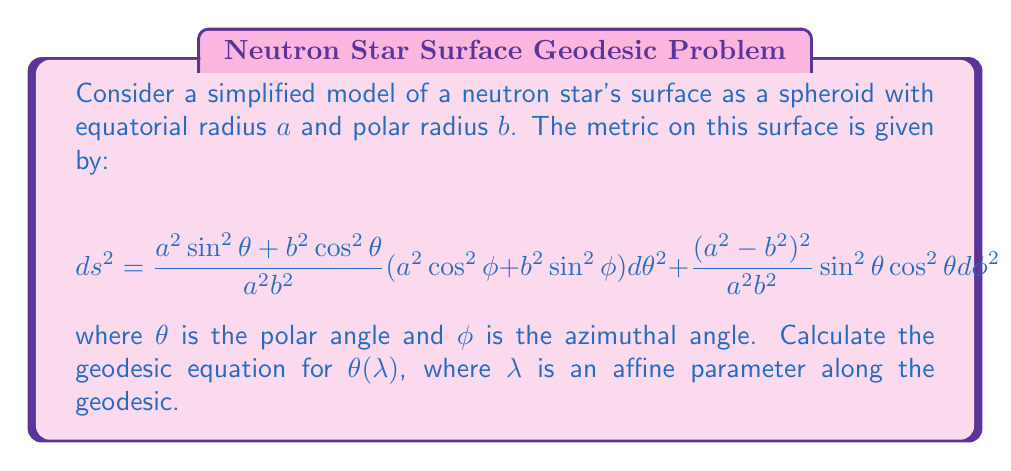Help me with this question. To find the geodesic equation for $\theta(\lambda)$, we'll use the Euler-Lagrange equation:

$$\frac{d}{d\lambda}\left(\frac{\partial L}{\partial \dot{\theta}}\right) - \frac{\partial L}{\partial \theta} = 0$$

where $L = \frac{1}{2}g_{\mu\nu}\frac{dx^\mu}{d\lambda}\frac{dx^\nu}{d\lambda}$ is the Lagrangian.

Step 1: Write out the Lagrangian
$$L = \frac{1}{2}\left[\frac{a^2\sin^2\theta + b^2\cos^2\theta}{a^2b^2}(a^2\cos^2\phi + b^2\sin^2\phi)\dot{\theta}^2 + \frac{(a^2-b^2)^2}{a^2b^2}\sin^2\theta\cos^2\theta \dot{\phi}^2\right]$$

Step 2: Calculate $\frac{\partial L}{\partial \dot{\theta}}$
$$\frac{\partial L}{\partial \dot{\theta}} = \frac{a^2\sin^2\theta + b^2\cos^2\theta}{a^2b^2}(a^2\cos^2\phi + b^2\sin^2\phi)\dot{\theta}$$

Step 3: Calculate $\frac{d}{d\lambda}\left(\frac{\partial L}{\partial \dot{\theta}}\right)$
$$\frac{d}{d\lambda}\left(\frac{\partial L}{\partial \dot{\theta}}\right) = \frac{d}{d\lambda}\left[\frac{a^2\sin^2\theta + b^2\cos^2\theta}{a^2b^2}(a^2\cos^2\phi + b^2\sin^2\phi)\dot{\theta}\right]$$

Step 4: Calculate $\frac{\partial L}{\partial \theta}$
$$\frac{\partial L}{\partial \theta} = \frac{1}{2}\left[\frac{2(a^2-b^2)\sin\theta\cos\theta}{a^2b^2}(a^2\cos^2\phi + b^2\sin^2\phi)\dot{\theta}^2 + \frac{(a^2-b^2)^2}{a^2b^2}(2\sin\theta\cos^3\theta - 2\sin^3\theta\cos\theta)\dot{\phi}^2\right]$$

Step 5: Substitute into the Euler-Lagrange equation and simplify
After substitution and simplification, we get:

$$(a^2\sin^2\theta + b^2\cos^2\theta)(a^2\cos^2\phi + b^2\sin^2\phi)\ddot{\theta} + (a^2-b^2)\sin\theta\cos\theta(a^2\cos^2\phi + b^2\sin^2\phi)\dot{\theta}^2 - \frac{1}{2}(a^2-b^2)^2\sin\theta\cos\theta(1-2\sin^2\theta)\dot{\phi}^2 = 0$$

This is the geodesic equation for $\theta(\lambda)$ on the surface of the neutron star modeled as a spheroid.
Answer: $$(a^2\sin^2\theta + b^2\cos^2\theta)(a^2\cos^2\phi + b^2\sin^2\phi)\ddot{\theta} + (a^2-b^2)\sin\theta\cos\theta(a^2\cos^2\phi + b^2\sin^2\phi)\dot{\theta}^2 - \frac{1}{2}(a^2-b^2)^2\sin\theta\cos\theta(1-2\sin^2\theta)\dot{\phi}^2 = 0$$ 